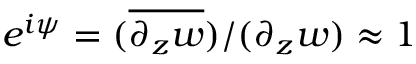Convert formula to latex. <formula><loc_0><loc_0><loc_500><loc_500>e ^ { i \psi } = ( \overline { { \partial _ { z } w } } ) / ( \partial _ { z } w ) \approx 1</formula> 